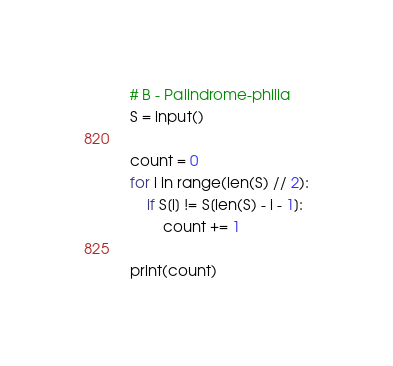<code> <loc_0><loc_0><loc_500><loc_500><_Python_># B - Palindrome-philia
S = input()

count = 0
for i in range(len(S) // 2):
    if S[i] != S[len(S) - i - 1]:
        count += 1

print(count)
</code> 